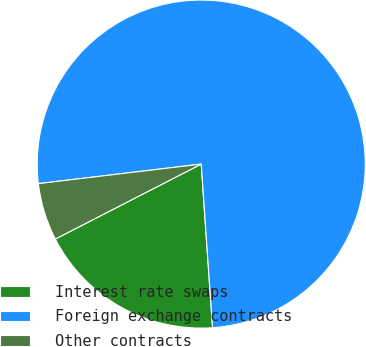Convert chart. <chart><loc_0><loc_0><loc_500><loc_500><pie_chart><fcel>Interest rate swaps<fcel>Foreign exchange contracts<fcel>Other contracts<nl><fcel>18.55%<fcel>75.81%<fcel>5.65%<nl></chart> 